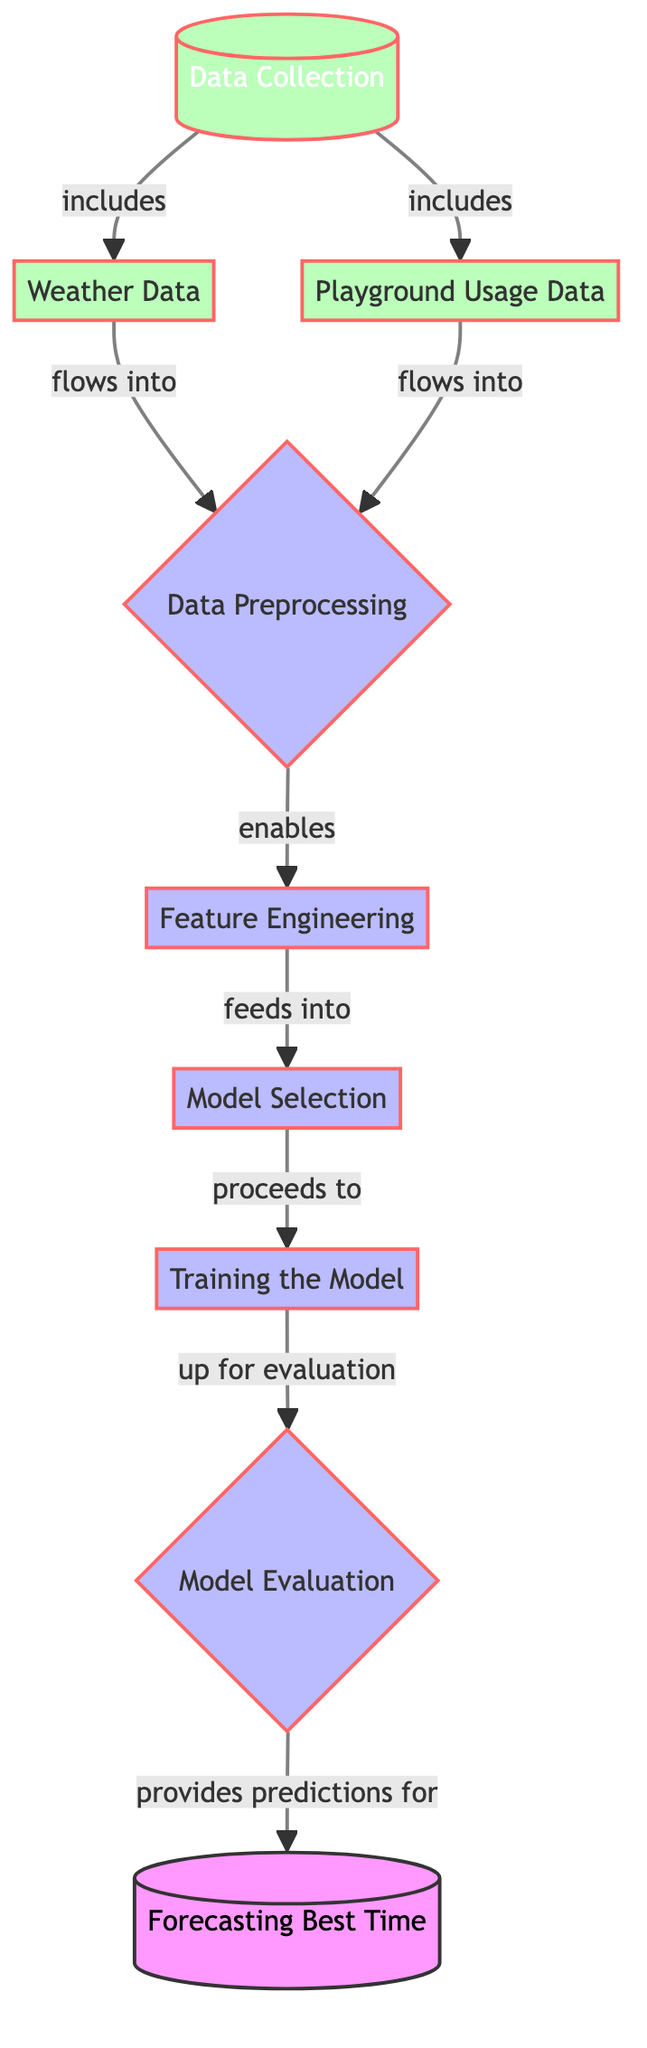What is the first step in the machine learning process? The diagram shows that the first step is "Data Collection." It is the very first node in the flowchart, indicating that this step initiates the entire analysis process.
Answer: Data Collection How many data sources are initially collected? The diagram indicates there are two data sources: "Weather Data" and "Playground Usage Data." Both of these nodes flow from "Data Collection," showing they are included in this initial step.
Answer: Two What step follows data preprocessing? According to the diagram flow, after "Data Preprocessing," the next step is "Feature Engineering." This is the connection made via the arrows in the flowchart that outline the sequential steps of the process.
Answer: Feature Engineering Which process provides predictions for forecasting? The diagram clearly indicates that "Model Evaluation" is the process that directly provides data for "Forecasting Best Time." This is shown by the arrow flowing from the evaluation step to the forecasting step.
Answer: Model Evaluation What is the relationship between weather data and data preprocessing? The relationship is that "Weather Data" flows into "Data Preprocessing." This connection is depicted in the diagram through an arrow indicating that weather data contributes to the preprocessing phase.
Answer: Flows into How many processes occur between feature engineering and model evaluation? Between "Feature Engineering" and "Model Evaluation," there are two processes: "Model Selection" and "Training the Model." The diagram outlines this sequence clearly through the flow of arrows connecting these nodes.
Answer: Two What is the final outcome of the machine learning process represented in the diagram? The final outcome of the machine learning process as shown in the flowchart is "Forecasting Best Time." This is identified as the last node in the flow, confirming it as the end result of the entire analysis.
Answer: Forecasting Best Time What step includes both weather data and playground usage data? The step that includes both types of data is "Data Preprocessing." The diagram shows both sources flowing into this step, indicating their integration in preprocessing activities.
Answer: Data Preprocessing What step occurs directly after training the model? The step that occurs directly after "Training the Model" is "Model Evaluation." This is shown in the diagram as the next process, continuing the sequence of the machine learning workflow.
Answer: Model Evaluation 